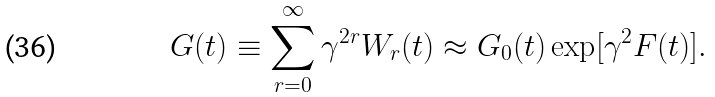Convert formula to latex. <formula><loc_0><loc_0><loc_500><loc_500>G ( t ) \equiv \sum _ { r = 0 } ^ { \infty } \gamma ^ { 2 r } W _ { r } ( t ) \approx G _ { 0 } ( t ) \exp [ \gamma ^ { 2 } F ( t ) ] .</formula> 